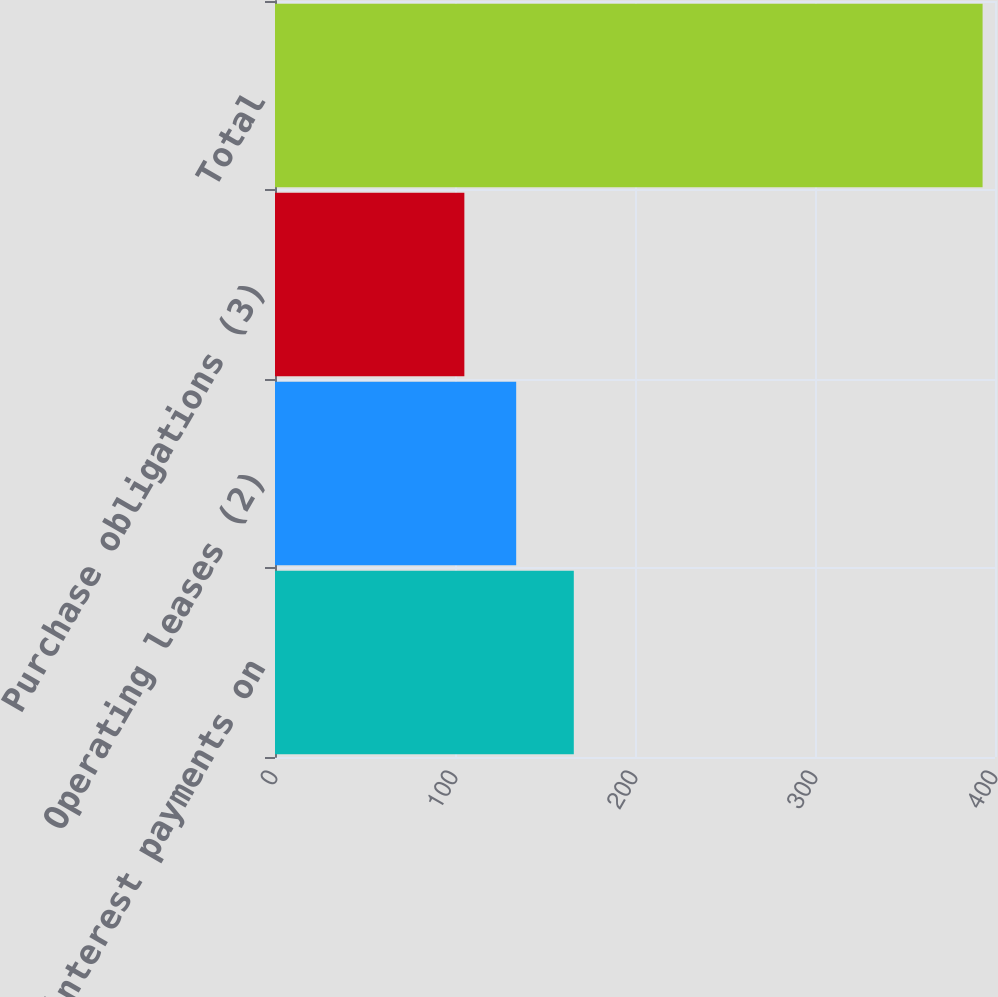Convert chart to OTSL. <chart><loc_0><loc_0><loc_500><loc_500><bar_chart><fcel>Estimated interest payments on<fcel>Operating leases (2)<fcel>Purchase obligations (3)<fcel>Total<nl><fcel>166<fcel>133.99<fcel>105.2<fcel>393.1<nl></chart> 